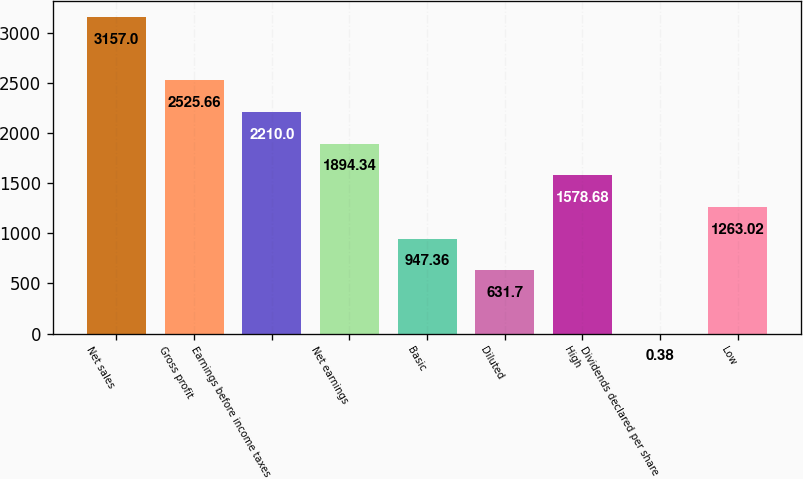Convert chart to OTSL. <chart><loc_0><loc_0><loc_500><loc_500><bar_chart><fcel>Net sales<fcel>Gross profit<fcel>Earnings before income taxes<fcel>Net earnings<fcel>Basic<fcel>Diluted<fcel>High<fcel>Dividends declared per share<fcel>Low<nl><fcel>3157<fcel>2525.66<fcel>2210<fcel>1894.34<fcel>947.36<fcel>631.7<fcel>1578.68<fcel>0.38<fcel>1263.02<nl></chart> 